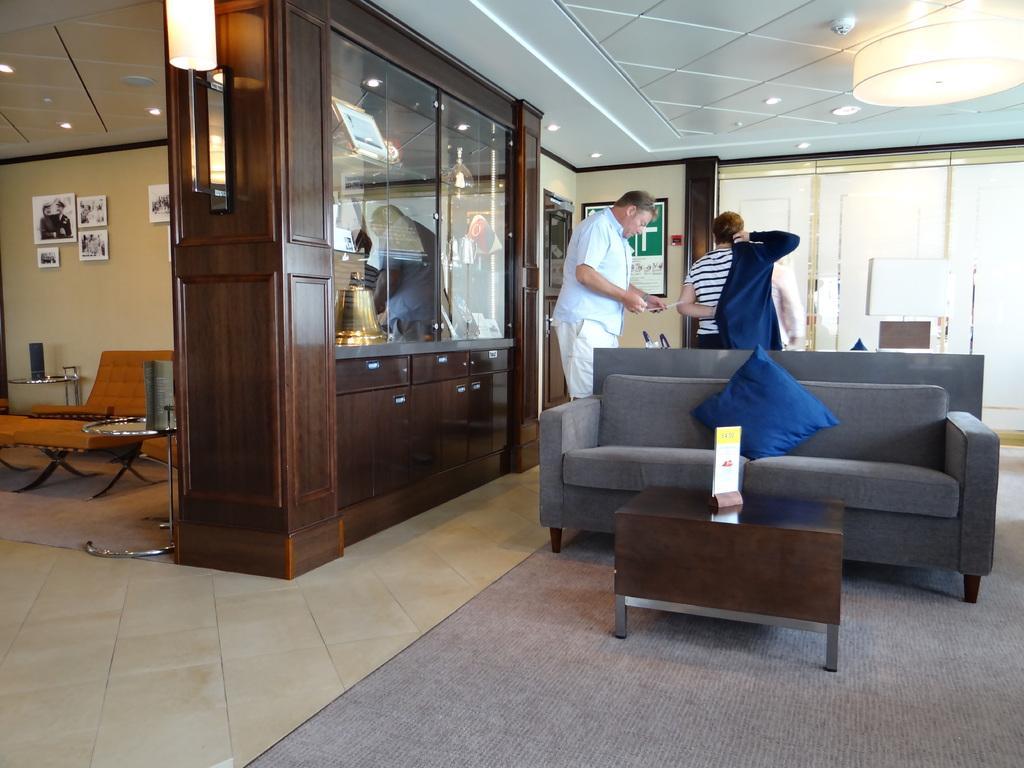How would you summarize this image in a sentence or two? The image is taken inside the building. In the center of the image there is a sofa and cushion placed on the sofa. There is a table. On the left there is a couch. In the background there are wall frames which are attached to the wall. There are two people standing. At the top there are lights. 